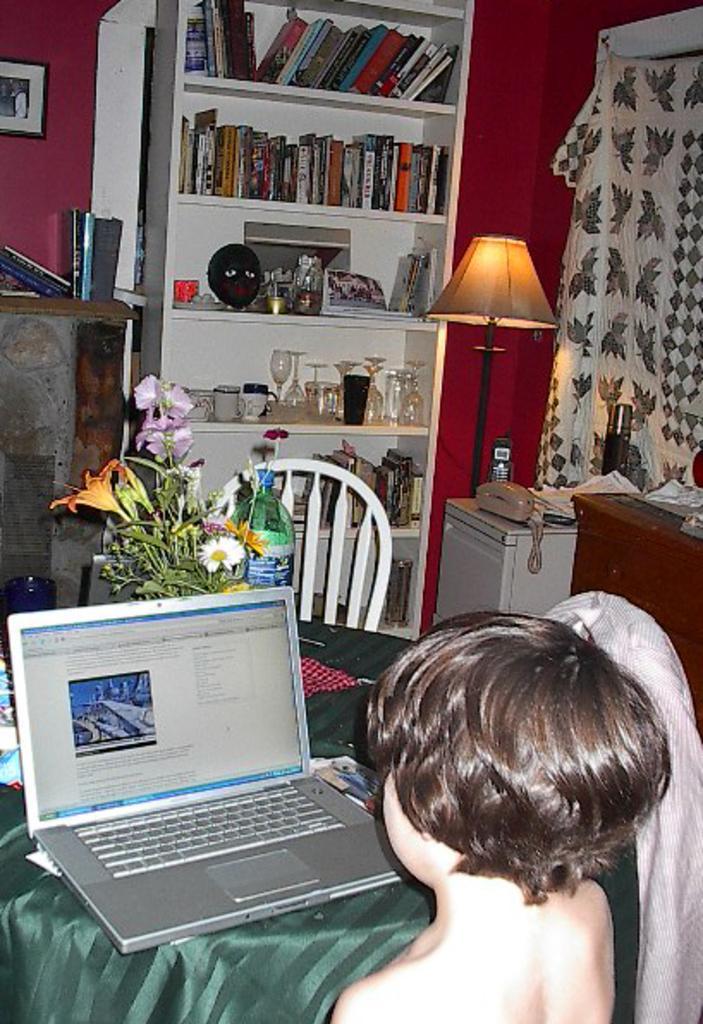In one or two sentences, can you explain what this image depicts? In the center of the image there is a table. On which there are many objects. In the bottom of the image there is a boy. In the background of the image there is a bookshelf. There is a wall. 